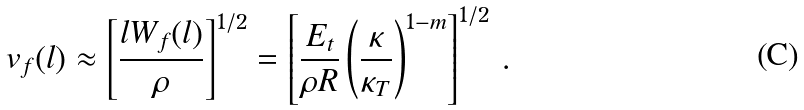Convert formula to latex. <formula><loc_0><loc_0><loc_500><loc_500>v _ { f } ( l ) \approx \left [ \frac { l W _ { f } ( l ) } { \rho } \right ] ^ { 1 / 2 } = \left [ \frac { E _ { t } } { \rho R } \left ( \frac { \kappa } { \kappa _ { T } } \right ) ^ { 1 - m } \right ] ^ { 1 / 2 } \, .</formula> 